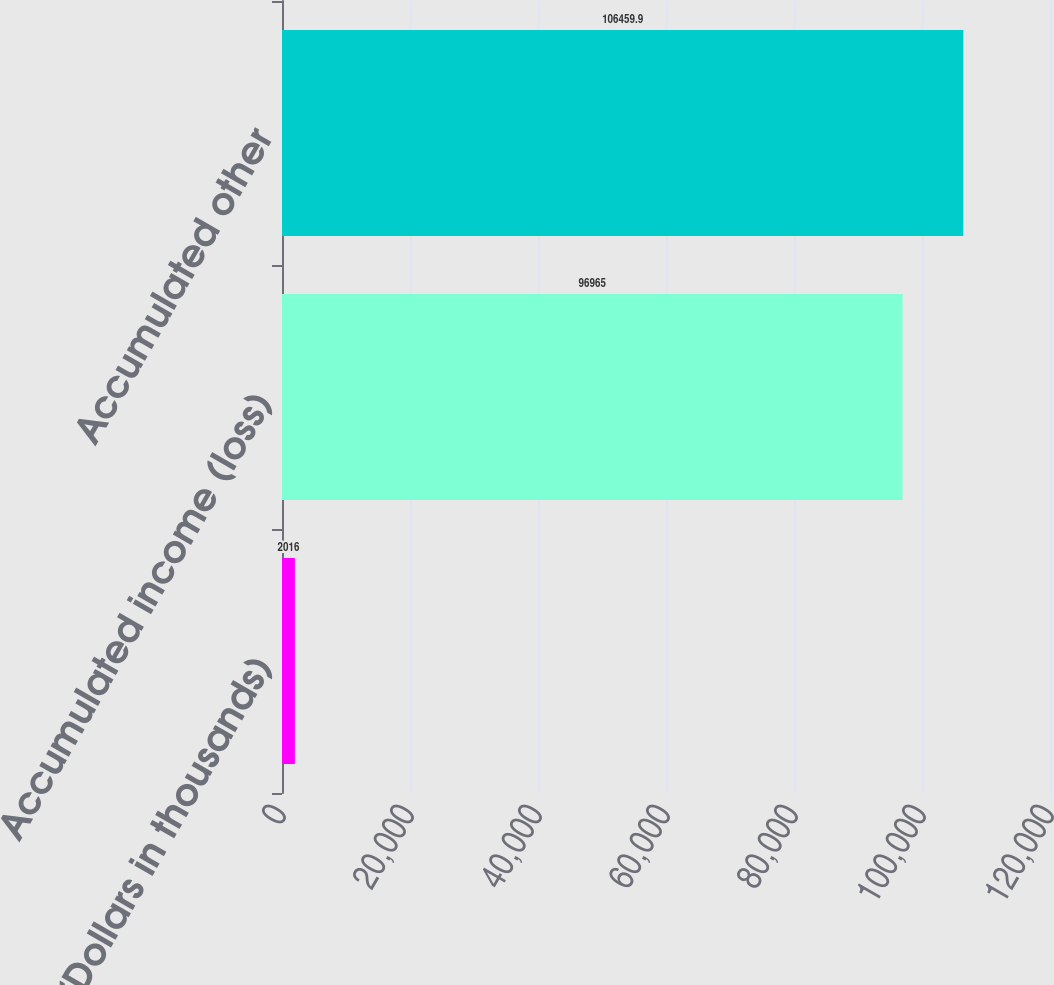<chart> <loc_0><loc_0><loc_500><loc_500><bar_chart><fcel>(Dollars in thousands)<fcel>Accumulated income (loss)<fcel>Accumulated other<nl><fcel>2016<fcel>96965<fcel>106460<nl></chart> 